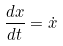Convert formula to latex. <formula><loc_0><loc_0><loc_500><loc_500>\frac { d x } { d t } = \dot { x }</formula> 